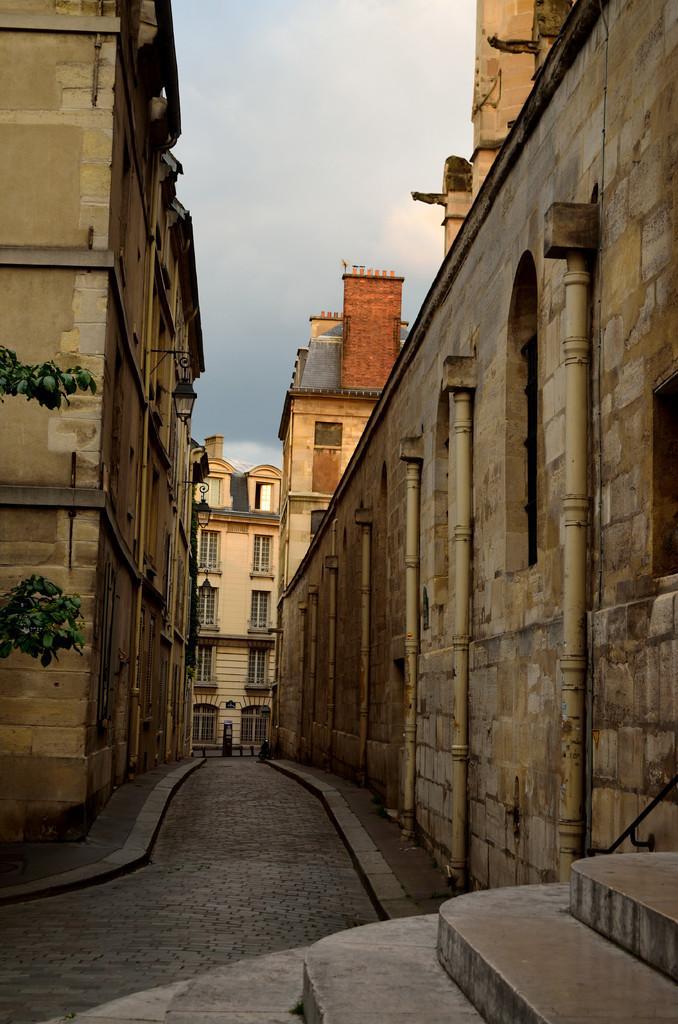Can you describe this image briefly? In this image there is a pavement in the middle. There are buildings on either side of it. At the top there is the sky. There are pipes attached to the building. At the bottom there are steps. On the left side there are plants. 